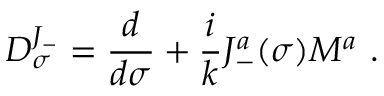<formula> <loc_0><loc_0><loc_500><loc_500>D _ { \sigma } ^ { J _ { - } } = \frac { d } { d \sigma } + \frac { i } { k } J _ { - } ^ { a } ( \sigma ) M ^ { a } .</formula> 